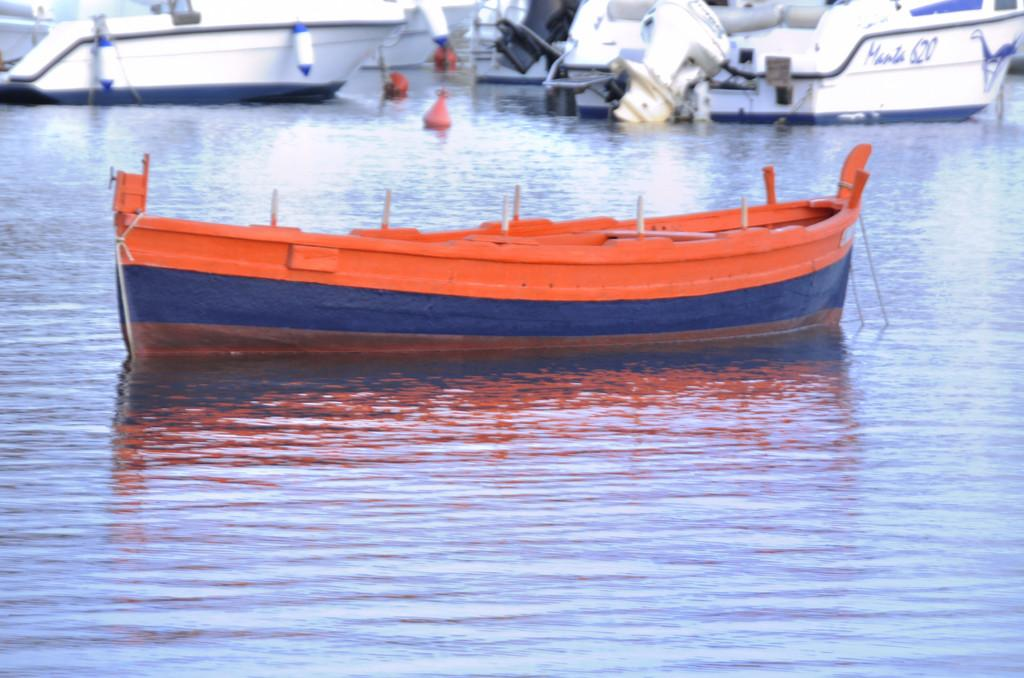<image>
Write a terse but informative summary of the picture. Orange boat in the water next to a white boat that says 620 in blue. 